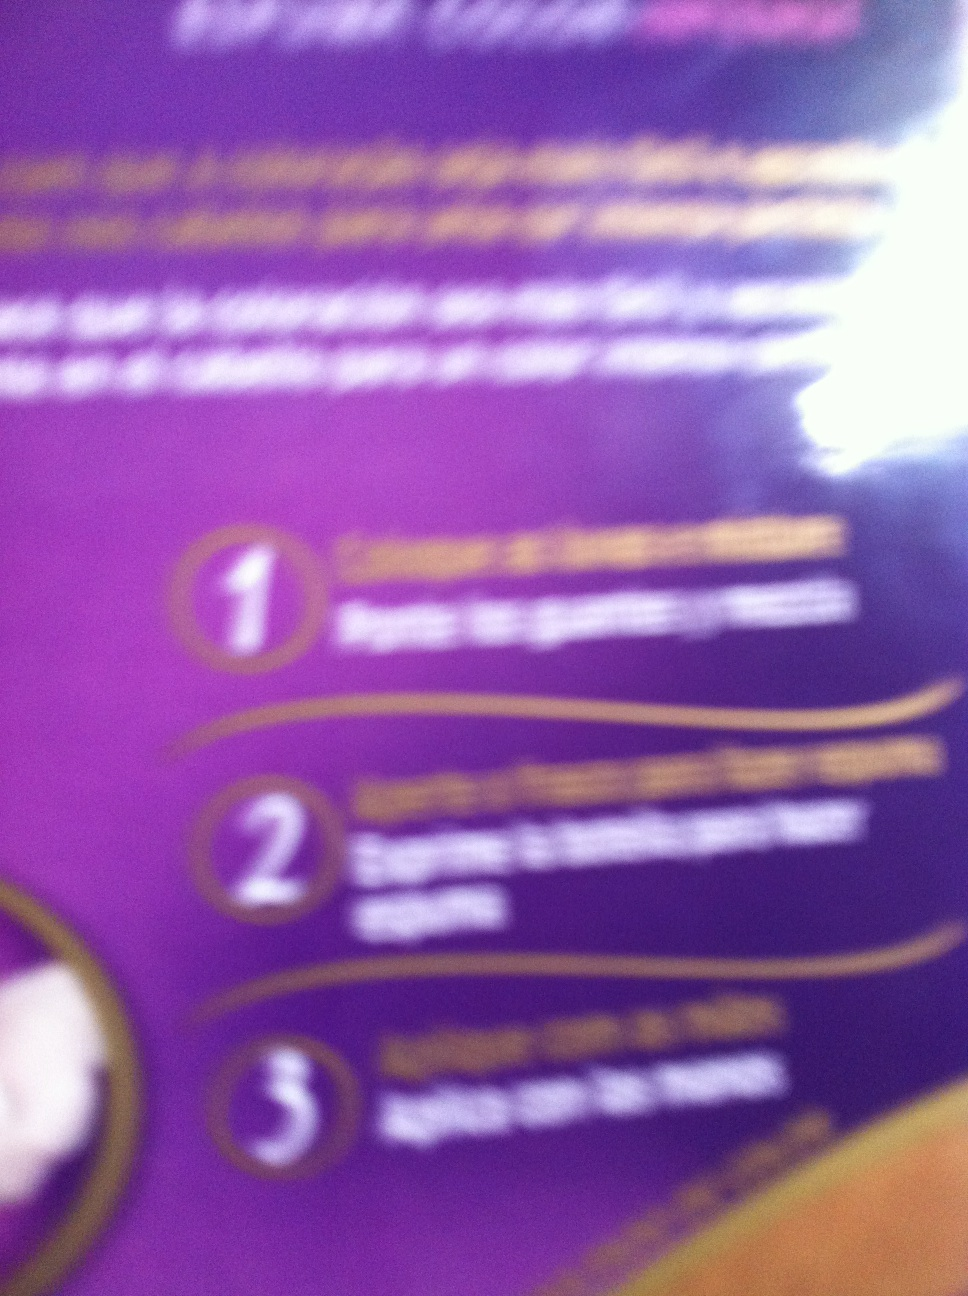What are some potential uses for this product based on the instructions? Based on the instructions, potential uses for this product might include moisturizing the skin, providing a protective barrier, or delivering specific active ingredients to improve skin health. It might be intended for daily use as part of a personal care routine. 